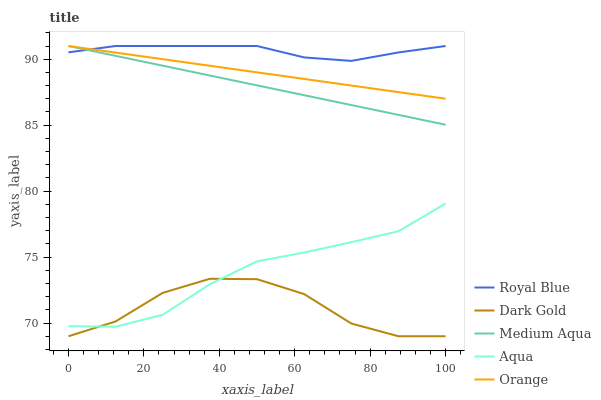Does Dark Gold have the minimum area under the curve?
Answer yes or no. Yes. Does Royal Blue have the maximum area under the curve?
Answer yes or no. Yes. Does Orange have the minimum area under the curve?
Answer yes or no. No. Does Orange have the maximum area under the curve?
Answer yes or no. No. Is Medium Aqua the smoothest?
Answer yes or no. Yes. Is Dark Gold the roughest?
Answer yes or no. Yes. Is Royal Blue the smoothest?
Answer yes or no. No. Is Royal Blue the roughest?
Answer yes or no. No. Does Dark Gold have the lowest value?
Answer yes or no. Yes. Does Orange have the lowest value?
Answer yes or no. No. Does Medium Aqua have the highest value?
Answer yes or no. Yes. Does Dark Gold have the highest value?
Answer yes or no. No. Is Dark Gold less than Medium Aqua?
Answer yes or no. Yes. Is Orange greater than Dark Gold?
Answer yes or no. Yes. Does Aqua intersect Dark Gold?
Answer yes or no. Yes. Is Aqua less than Dark Gold?
Answer yes or no. No. Is Aqua greater than Dark Gold?
Answer yes or no. No. Does Dark Gold intersect Medium Aqua?
Answer yes or no. No. 